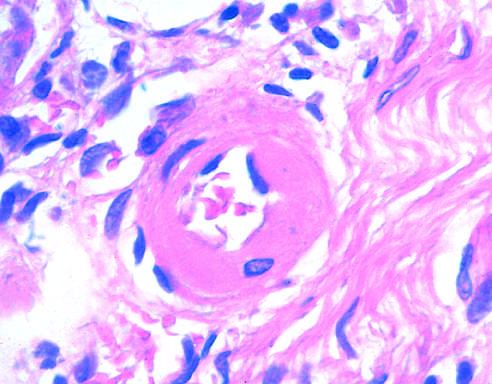what is markedly narrowed?
Answer the question using a single word or phrase. The lumen 